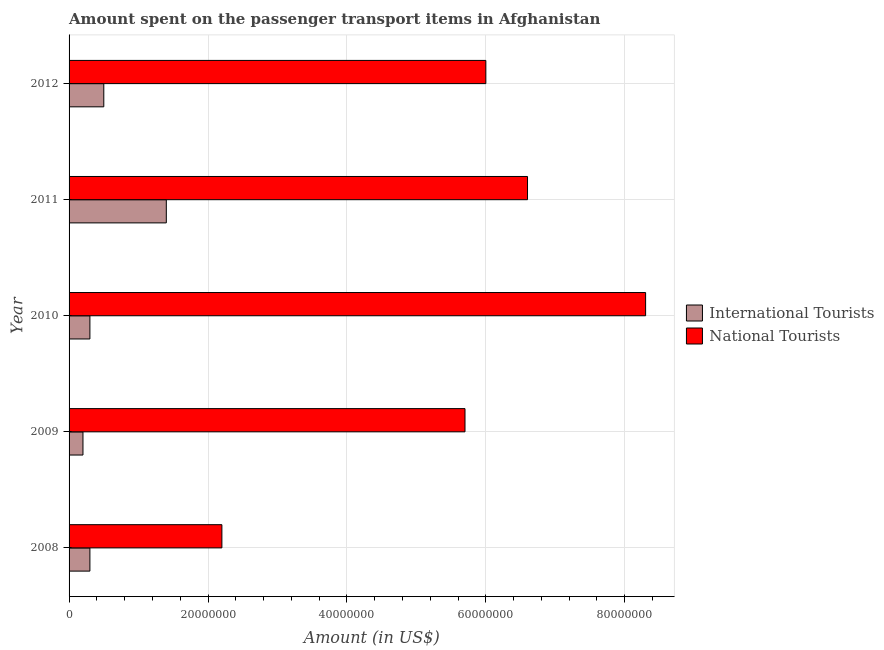How many groups of bars are there?
Offer a very short reply. 5. Are the number of bars on each tick of the Y-axis equal?
Your response must be concise. Yes. How many bars are there on the 3rd tick from the top?
Ensure brevity in your answer.  2. How many bars are there on the 3rd tick from the bottom?
Your answer should be compact. 2. What is the amount spent on transport items of national tourists in 2008?
Offer a very short reply. 2.20e+07. Across all years, what is the maximum amount spent on transport items of international tourists?
Your answer should be compact. 1.40e+07. Across all years, what is the minimum amount spent on transport items of national tourists?
Your answer should be compact. 2.20e+07. In which year was the amount spent on transport items of national tourists maximum?
Make the answer very short. 2010. In which year was the amount spent on transport items of international tourists minimum?
Provide a short and direct response. 2009. What is the total amount spent on transport items of international tourists in the graph?
Make the answer very short. 2.70e+07. What is the difference between the amount spent on transport items of national tourists in 2008 and that in 2010?
Your answer should be compact. -6.10e+07. What is the difference between the amount spent on transport items of international tourists in 2012 and the amount spent on transport items of national tourists in 2009?
Make the answer very short. -5.20e+07. What is the average amount spent on transport items of international tourists per year?
Offer a very short reply. 5.40e+06. In the year 2012, what is the difference between the amount spent on transport items of international tourists and amount spent on transport items of national tourists?
Your response must be concise. -5.50e+07. What is the ratio of the amount spent on transport items of national tourists in 2010 to that in 2012?
Provide a succinct answer. 1.38. What is the difference between the highest and the second highest amount spent on transport items of national tourists?
Provide a short and direct response. 1.70e+07. What is the difference between the highest and the lowest amount spent on transport items of national tourists?
Your response must be concise. 6.10e+07. Is the sum of the amount spent on transport items of international tourists in 2009 and 2012 greater than the maximum amount spent on transport items of national tourists across all years?
Make the answer very short. No. What does the 1st bar from the top in 2012 represents?
Give a very brief answer. National Tourists. What does the 2nd bar from the bottom in 2009 represents?
Give a very brief answer. National Tourists. Does the graph contain any zero values?
Offer a very short reply. No. Where does the legend appear in the graph?
Make the answer very short. Center right. How are the legend labels stacked?
Make the answer very short. Vertical. What is the title of the graph?
Provide a short and direct response. Amount spent on the passenger transport items in Afghanistan. Does "Goods" appear as one of the legend labels in the graph?
Provide a succinct answer. No. What is the label or title of the X-axis?
Offer a very short reply. Amount (in US$). What is the label or title of the Y-axis?
Offer a terse response. Year. What is the Amount (in US$) in National Tourists in 2008?
Your response must be concise. 2.20e+07. What is the Amount (in US$) of National Tourists in 2009?
Your answer should be compact. 5.70e+07. What is the Amount (in US$) of International Tourists in 2010?
Your answer should be compact. 3.00e+06. What is the Amount (in US$) of National Tourists in 2010?
Ensure brevity in your answer.  8.30e+07. What is the Amount (in US$) of International Tourists in 2011?
Ensure brevity in your answer.  1.40e+07. What is the Amount (in US$) of National Tourists in 2011?
Offer a terse response. 6.60e+07. What is the Amount (in US$) in National Tourists in 2012?
Provide a short and direct response. 6.00e+07. Across all years, what is the maximum Amount (in US$) of International Tourists?
Offer a very short reply. 1.40e+07. Across all years, what is the maximum Amount (in US$) of National Tourists?
Make the answer very short. 8.30e+07. Across all years, what is the minimum Amount (in US$) of National Tourists?
Your answer should be very brief. 2.20e+07. What is the total Amount (in US$) in International Tourists in the graph?
Your answer should be very brief. 2.70e+07. What is the total Amount (in US$) of National Tourists in the graph?
Keep it short and to the point. 2.88e+08. What is the difference between the Amount (in US$) of National Tourists in 2008 and that in 2009?
Ensure brevity in your answer.  -3.50e+07. What is the difference between the Amount (in US$) in National Tourists in 2008 and that in 2010?
Offer a terse response. -6.10e+07. What is the difference between the Amount (in US$) of International Tourists in 2008 and that in 2011?
Offer a terse response. -1.10e+07. What is the difference between the Amount (in US$) of National Tourists in 2008 and that in 2011?
Ensure brevity in your answer.  -4.40e+07. What is the difference between the Amount (in US$) of International Tourists in 2008 and that in 2012?
Make the answer very short. -2.00e+06. What is the difference between the Amount (in US$) in National Tourists in 2008 and that in 2012?
Provide a succinct answer. -3.80e+07. What is the difference between the Amount (in US$) in International Tourists in 2009 and that in 2010?
Make the answer very short. -1.00e+06. What is the difference between the Amount (in US$) in National Tourists in 2009 and that in 2010?
Provide a succinct answer. -2.60e+07. What is the difference between the Amount (in US$) in International Tourists in 2009 and that in 2011?
Your answer should be compact. -1.20e+07. What is the difference between the Amount (in US$) of National Tourists in 2009 and that in 2011?
Offer a terse response. -9.00e+06. What is the difference between the Amount (in US$) of International Tourists in 2010 and that in 2011?
Your response must be concise. -1.10e+07. What is the difference between the Amount (in US$) in National Tourists in 2010 and that in 2011?
Your answer should be very brief. 1.70e+07. What is the difference between the Amount (in US$) in International Tourists in 2010 and that in 2012?
Provide a succinct answer. -2.00e+06. What is the difference between the Amount (in US$) of National Tourists in 2010 and that in 2012?
Offer a very short reply. 2.30e+07. What is the difference between the Amount (in US$) in International Tourists in 2011 and that in 2012?
Provide a succinct answer. 9.00e+06. What is the difference between the Amount (in US$) in International Tourists in 2008 and the Amount (in US$) in National Tourists in 2009?
Make the answer very short. -5.40e+07. What is the difference between the Amount (in US$) in International Tourists in 2008 and the Amount (in US$) in National Tourists in 2010?
Ensure brevity in your answer.  -8.00e+07. What is the difference between the Amount (in US$) in International Tourists in 2008 and the Amount (in US$) in National Tourists in 2011?
Your answer should be very brief. -6.30e+07. What is the difference between the Amount (in US$) in International Tourists in 2008 and the Amount (in US$) in National Tourists in 2012?
Make the answer very short. -5.70e+07. What is the difference between the Amount (in US$) in International Tourists in 2009 and the Amount (in US$) in National Tourists in 2010?
Offer a terse response. -8.10e+07. What is the difference between the Amount (in US$) in International Tourists in 2009 and the Amount (in US$) in National Tourists in 2011?
Your answer should be compact. -6.40e+07. What is the difference between the Amount (in US$) of International Tourists in 2009 and the Amount (in US$) of National Tourists in 2012?
Provide a short and direct response. -5.80e+07. What is the difference between the Amount (in US$) in International Tourists in 2010 and the Amount (in US$) in National Tourists in 2011?
Provide a short and direct response. -6.30e+07. What is the difference between the Amount (in US$) of International Tourists in 2010 and the Amount (in US$) of National Tourists in 2012?
Ensure brevity in your answer.  -5.70e+07. What is the difference between the Amount (in US$) of International Tourists in 2011 and the Amount (in US$) of National Tourists in 2012?
Your answer should be compact. -4.60e+07. What is the average Amount (in US$) in International Tourists per year?
Your answer should be very brief. 5.40e+06. What is the average Amount (in US$) in National Tourists per year?
Provide a short and direct response. 5.76e+07. In the year 2008, what is the difference between the Amount (in US$) of International Tourists and Amount (in US$) of National Tourists?
Ensure brevity in your answer.  -1.90e+07. In the year 2009, what is the difference between the Amount (in US$) of International Tourists and Amount (in US$) of National Tourists?
Offer a terse response. -5.50e+07. In the year 2010, what is the difference between the Amount (in US$) of International Tourists and Amount (in US$) of National Tourists?
Keep it short and to the point. -8.00e+07. In the year 2011, what is the difference between the Amount (in US$) of International Tourists and Amount (in US$) of National Tourists?
Your response must be concise. -5.20e+07. In the year 2012, what is the difference between the Amount (in US$) in International Tourists and Amount (in US$) in National Tourists?
Your answer should be very brief. -5.50e+07. What is the ratio of the Amount (in US$) of National Tourists in 2008 to that in 2009?
Your answer should be compact. 0.39. What is the ratio of the Amount (in US$) in National Tourists in 2008 to that in 2010?
Provide a succinct answer. 0.27. What is the ratio of the Amount (in US$) of International Tourists in 2008 to that in 2011?
Your answer should be very brief. 0.21. What is the ratio of the Amount (in US$) of National Tourists in 2008 to that in 2012?
Make the answer very short. 0.37. What is the ratio of the Amount (in US$) of International Tourists in 2009 to that in 2010?
Provide a succinct answer. 0.67. What is the ratio of the Amount (in US$) in National Tourists in 2009 to that in 2010?
Your answer should be compact. 0.69. What is the ratio of the Amount (in US$) in International Tourists in 2009 to that in 2011?
Provide a short and direct response. 0.14. What is the ratio of the Amount (in US$) of National Tourists in 2009 to that in 2011?
Give a very brief answer. 0.86. What is the ratio of the Amount (in US$) in International Tourists in 2010 to that in 2011?
Your answer should be compact. 0.21. What is the ratio of the Amount (in US$) of National Tourists in 2010 to that in 2011?
Your answer should be very brief. 1.26. What is the ratio of the Amount (in US$) of International Tourists in 2010 to that in 2012?
Your response must be concise. 0.6. What is the ratio of the Amount (in US$) in National Tourists in 2010 to that in 2012?
Keep it short and to the point. 1.38. What is the ratio of the Amount (in US$) in International Tourists in 2011 to that in 2012?
Your response must be concise. 2.8. What is the difference between the highest and the second highest Amount (in US$) of International Tourists?
Keep it short and to the point. 9.00e+06. What is the difference between the highest and the second highest Amount (in US$) in National Tourists?
Offer a very short reply. 1.70e+07. What is the difference between the highest and the lowest Amount (in US$) of National Tourists?
Your response must be concise. 6.10e+07. 